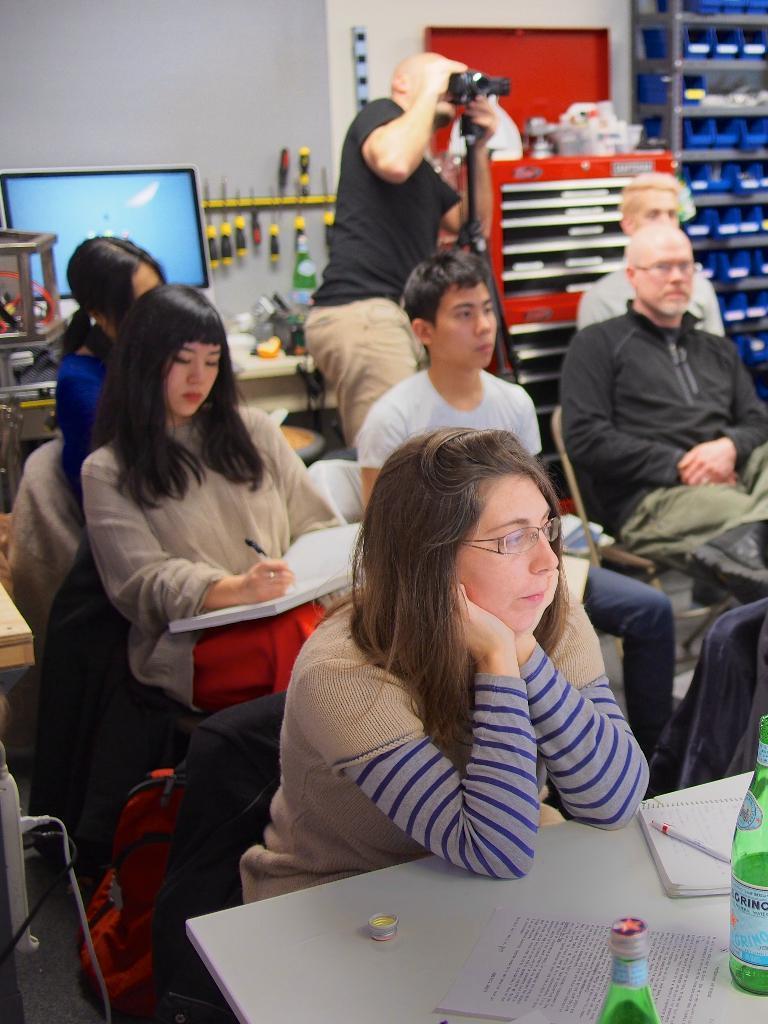How would you summarize this image in a sentence or two? This image is clicked in a room. There are so many people in this image. One of them who is on the back side is clicking pictures and all the other people are sitting. There is a monitor on the left side and there are cracks on the top right corner. There are tables and chairs on that table there are bottles, papers, books, pens. 